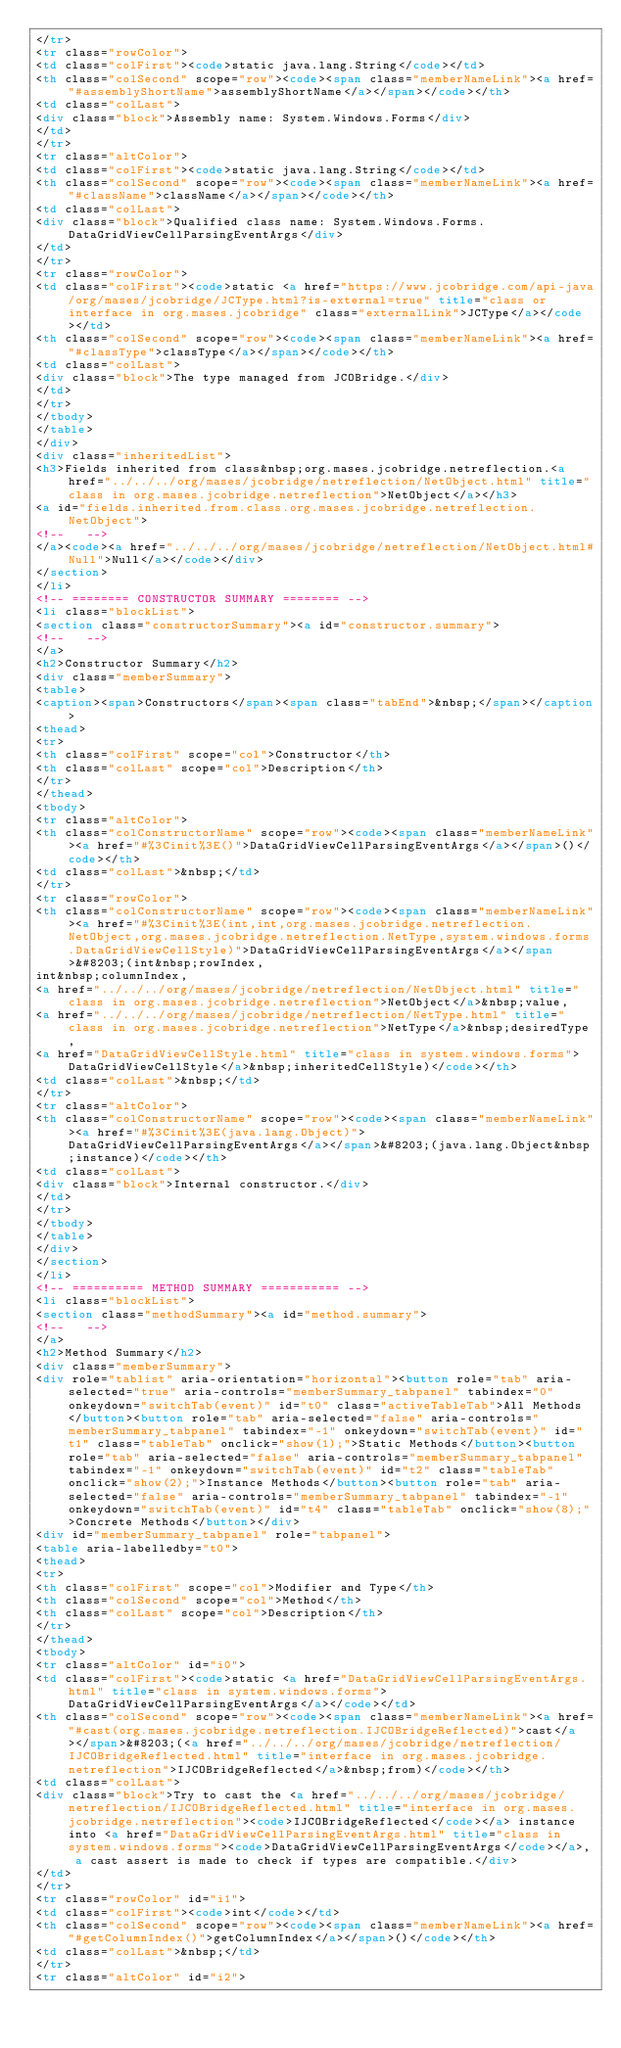<code> <loc_0><loc_0><loc_500><loc_500><_HTML_></tr>
<tr class="rowColor">
<td class="colFirst"><code>static java.lang.String</code></td>
<th class="colSecond" scope="row"><code><span class="memberNameLink"><a href="#assemblyShortName">assemblyShortName</a></span></code></th>
<td class="colLast">
<div class="block">Assembly name: System.Windows.Forms</div>
</td>
</tr>
<tr class="altColor">
<td class="colFirst"><code>static java.lang.String</code></td>
<th class="colSecond" scope="row"><code><span class="memberNameLink"><a href="#className">className</a></span></code></th>
<td class="colLast">
<div class="block">Qualified class name: System.Windows.Forms.DataGridViewCellParsingEventArgs</div>
</td>
</tr>
<tr class="rowColor">
<td class="colFirst"><code>static <a href="https://www.jcobridge.com/api-java/org/mases/jcobridge/JCType.html?is-external=true" title="class or interface in org.mases.jcobridge" class="externalLink">JCType</a></code></td>
<th class="colSecond" scope="row"><code><span class="memberNameLink"><a href="#classType">classType</a></span></code></th>
<td class="colLast">
<div class="block">The type managed from JCOBridge.</div>
</td>
</tr>
</tbody>
</table>
</div>
<div class="inheritedList">
<h3>Fields inherited from class&nbsp;org.mases.jcobridge.netreflection.<a href="../../../org/mases/jcobridge/netreflection/NetObject.html" title="class in org.mases.jcobridge.netreflection">NetObject</a></h3>
<a id="fields.inherited.from.class.org.mases.jcobridge.netreflection.NetObject">
<!--   -->
</a><code><a href="../../../org/mases/jcobridge/netreflection/NetObject.html#Null">Null</a></code></div>
</section>
</li>
<!-- ======== CONSTRUCTOR SUMMARY ======== -->
<li class="blockList">
<section class="constructorSummary"><a id="constructor.summary">
<!--   -->
</a>
<h2>Constructor Summary</h2>
<div class="memberSummary">
<table>
<caption><span>Constructors</span><span class="tabEnd">&nbsp;</span></caption>
<thead>
<tr>
<th class="colFirst" scope="col">Constructor</th>
<th class="colLast" scope="col">Description</th>
</tr>
</thead>
<tbody>
<tr class="altColor">
<th class="colConstructorName" scope="row"><code><span class="memberNameLink"><a href="#%3Cinit%3E()">DataGridViewCellParsingEventArgs</a></span>()</code></th>
<td class="colLast">&nbsp;</td>
</tr>
<tr class="rowColor">
<th class="colConstructorName" scope="row"><code><span class="memberNameLink"><a href="#%3Cinit%3E(int,int,org.mases.jcobridge.netreflection.NetObject,org.mases.jcobridge.netreflection.NetType,system.windows.forms.DataGridViewCellStyle)">DataGridViewCellParsingEventArgs</a></span>&#8203;(int&nbsp;rowIndex,
int&nbsp;columnIndex,
<a href="../../../org/mases/jcobridge/netreflection/NetObject.html" title="class in org.mases.jcobridge.netreflection">NetObject</a>&nbsp;value,
<a href="../../../org/mases/jcobridge/netreflection/NetType.html" title="class in org.mases.jcobridge.netreflection">NetType</a>&nbsp;desiredType,
<a href="DataGridViewCellStyle.html" title="class in system.windows.forms">DataGridViewCellStyle</a>&nbsp;inheritedCellStyle)</code></th>
<td class="colLast">&nbsp;</td>
</tr>
<tr class="altColor">
<th class="colConstructorName" scope="row"><code><span class="memberNameLink"><a href="#%3Cinit%3E(java.lang.Object)">DataGridViewCellParsingEventArgs</a></span>&#8203;(java.lang.Object&nbsp;instance)</code></th>
<td class="colLast">
<div class="block">Internal constructor.</div>
</td>
</tr>
</tbody>
</table>
</div>
</section>
</li>
<!-- ========== METHOD SUMMARY =========== -->
<li class="blockList">
<section class="methodSummary"><a id="method.summary">
<!--   -->
</a>
<h2>Method Summary</h2>
<div class="memberSummary">
<div role="tablist" aria-orientation="horizontal"><button role="tab" aria-selected="true" aria-controls="memberSummary_tabpanel" tabindex="0" onkeydown="switchTab(event)" id="t0" class="activeTableTab">All Methods</button><button role="tab" aria-selected="false" aria-controls="memberSummary_tabpanel" tabindex="-1" onkeydown="switchTab(event)" id="t1" class="tableTab" onclick="show(1);">Static Methods</button><button role="tab" aria-selected="false" aria-controls="memberSummary_tabpanel" tabindex="-1" onkeydown="switchTab(event)" id="t2" class="tableTab" onclick="show(2);">Instance Methods</button><button role="tab" aria-selected="false" aria-controls="memberSummary_tabpanel" tabindex="-1" onkeydown="switchTab(event)" id="t4" class="tableTab" onclick="show(8);">Concrete Methods</button></div>
<div id="memberSummary_tabpanel" role="tabpanel">
<table aria-labelledby="t0">
<thead>
<tr>
<th class="colFirst" scope="col">Modifier and Type</th>
<th class="colSecond" scope="col">Method</th>
<th class="colLast" scope="col">Description</th>
</tr>
</thead>
<tbody>
<tr class="altColor" id="i0">
<td class="colFirst"><code>static <a href="DataGridViewCellParsingEventArgs.html" title="class in system.windows.forms">DataGridViewCellParsingEventArgs</a></code></td>
<th class="colSecond" scope="row"><code><span class="memberNameLink"><a href="#cast(org.mases.jcobridge.netreflection.IJCOBridgeReflected)">cast</a></span>&#8203;(<a href="../../../org/mases/jcobridge/netreflection/IJCOBridgeReflected.html" title="interface in org.mases.jcobridge.netreflection">IJCOBridgeReflected</a>&nbsp;from)</code></th>
<td class="colLast">
<div class="block">Try to cast the <a href="../../../org/mases/jcobridge/netreflection/IJCOBridgeReflected.html" title="interface in org.mases.jcobridge.netreflection"><code>IJCOBridgeReflected</code></a> instance into <a href="DataGridViewCellParsingEventArgs.html" title="class in system.windows.forms"><code>DataGridViewCellParsingEventArgs</code></a>, a cast assert is made to check if types are compatible.</div>
</td>
</tr>
<tr class="rowColor" id="i1">
<td class="colFirst"><code>int</code></td>
<th class="colSecond" scope="row"><code><span class="memberNameLink"><a href="#getColumnIndex()">getColumnIndex</a></span>()</code></th>
<td class="colLast">&nbsp;</td>
</tr>
<tr class="altColor" id="i2"></code> 